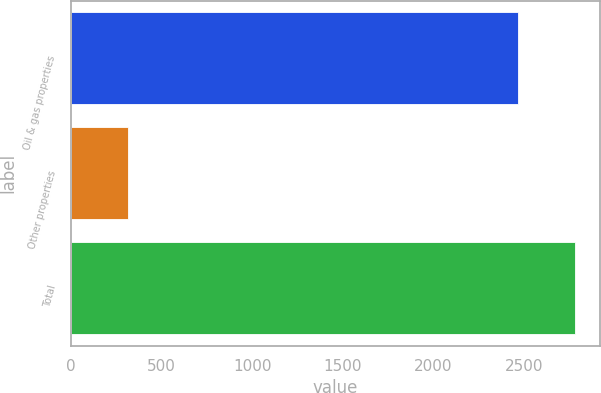Convert chart to OTSL. <chart><loc_0><loc_0><loc_500><loc_500><bar_chart><fcel>Oil & gas properties<fcel>Other properties<fcel>Total<nl><fcel>2465<fcel>315<fcel>2780<nl></chart> 